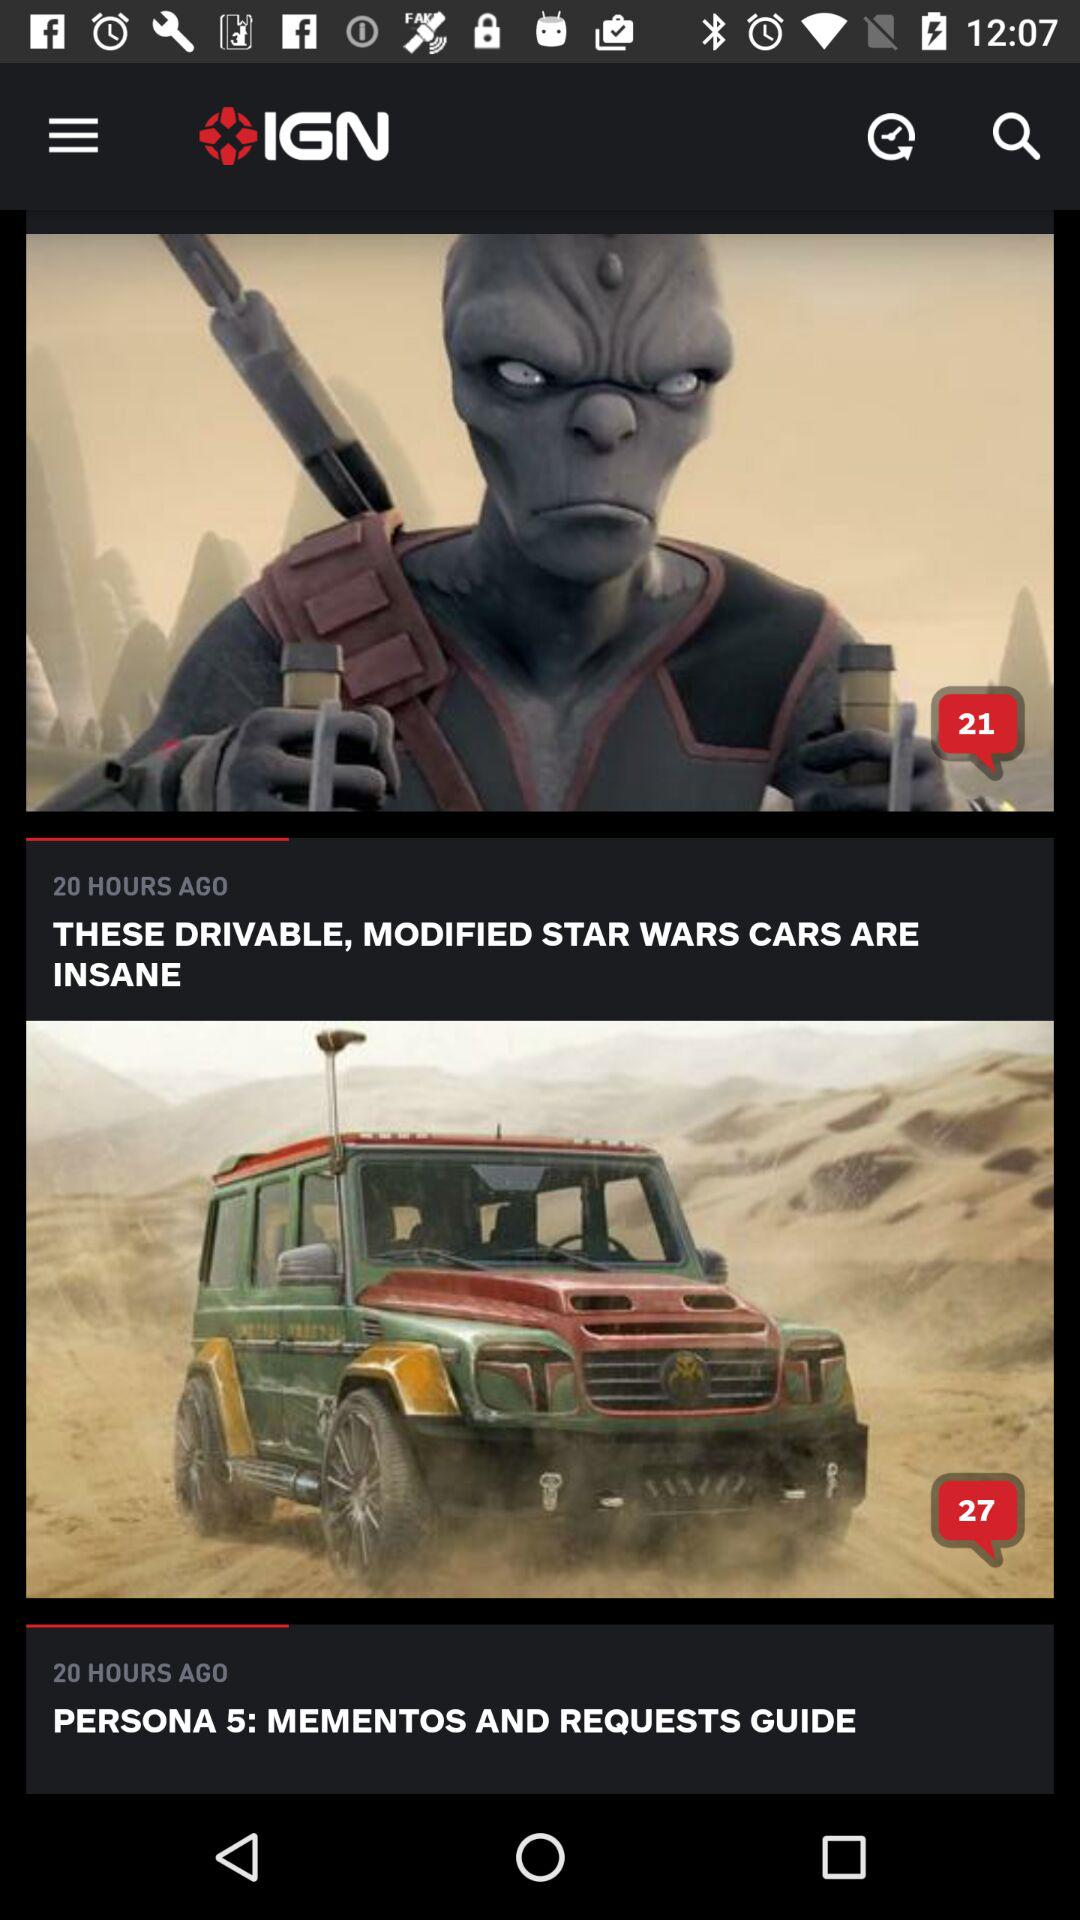How many hours ago was "THESE DRIVABLE, MODIFIED STAR WARS CARS ARE INSANE" posted? It was posted 20 hours ago. 